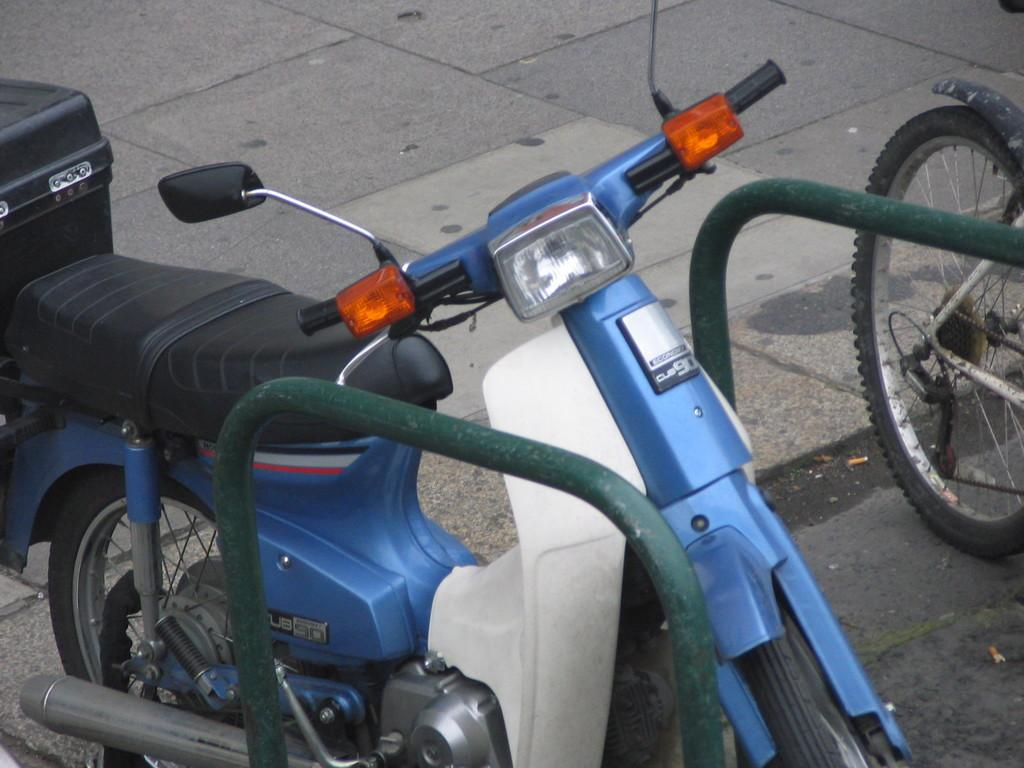What is parked on the path in the image? There is a bike parked on the path in the image. What can be seen on the right side of the path in the image? There is an iron rod and a bicycle wheel on the right side of the path in the image. What month is it in the image? The month cannot be determined from the image, as there is no information about the time or date. 